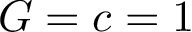Convert formula to latex. <formula><loc_0><loc_0><loc_500><loc_500>G = c = 1</formula> 